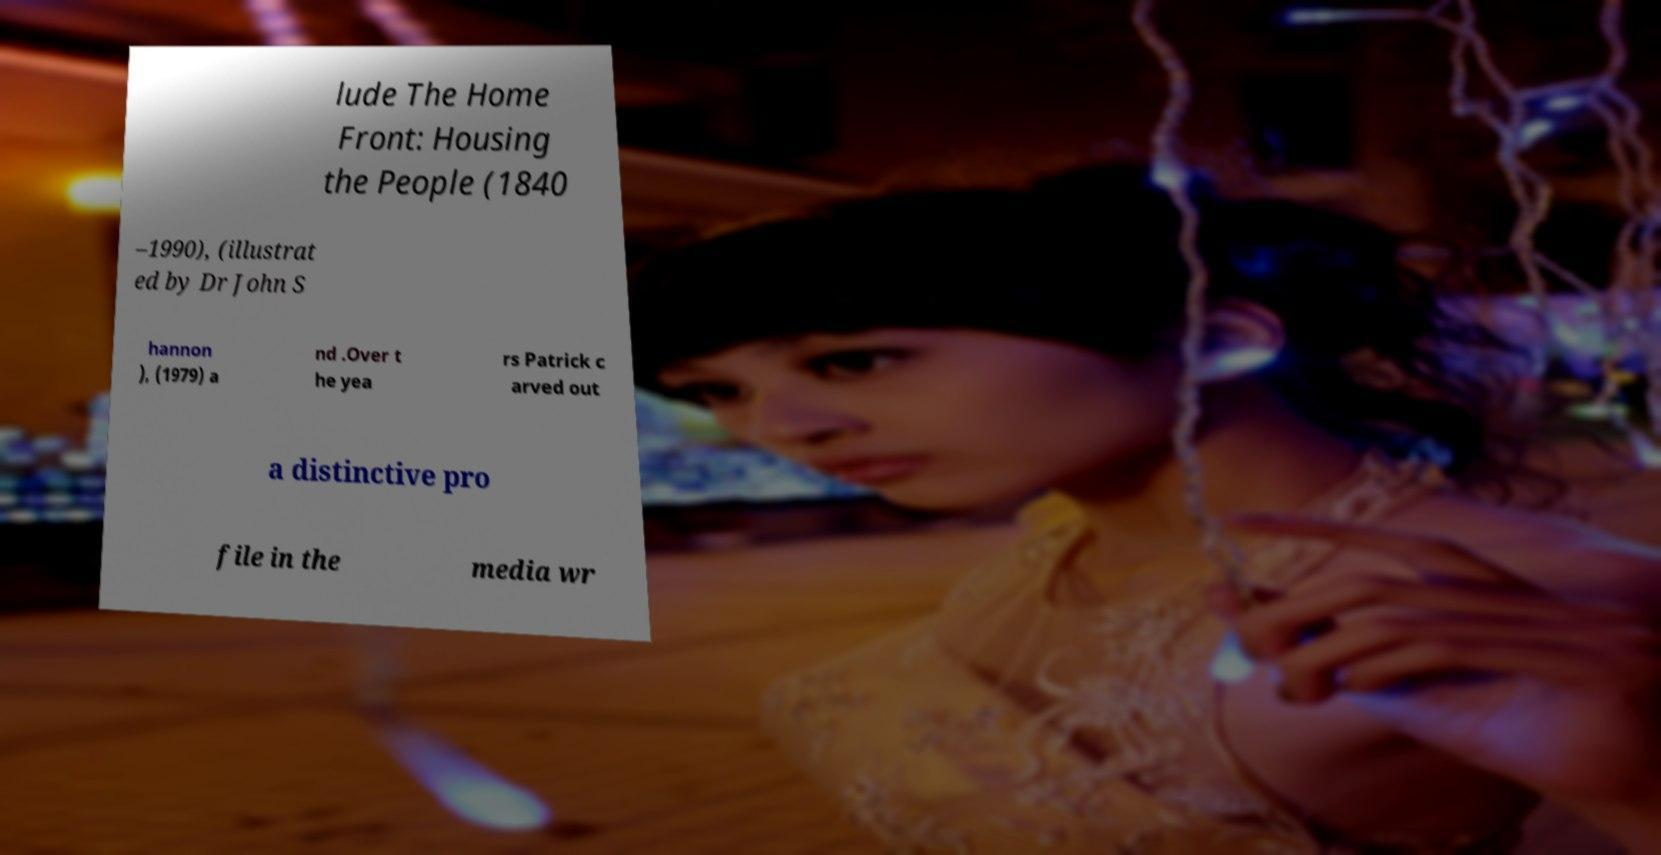Please identify and transcribe the text found in this image. lude The Home Front: Housing the People (1840 –1990), (illustrat ed by Dr John S hannon ), (1979) a nd .Over t he yea rs Patrick c arved out a distinctive pro file in the media wr 